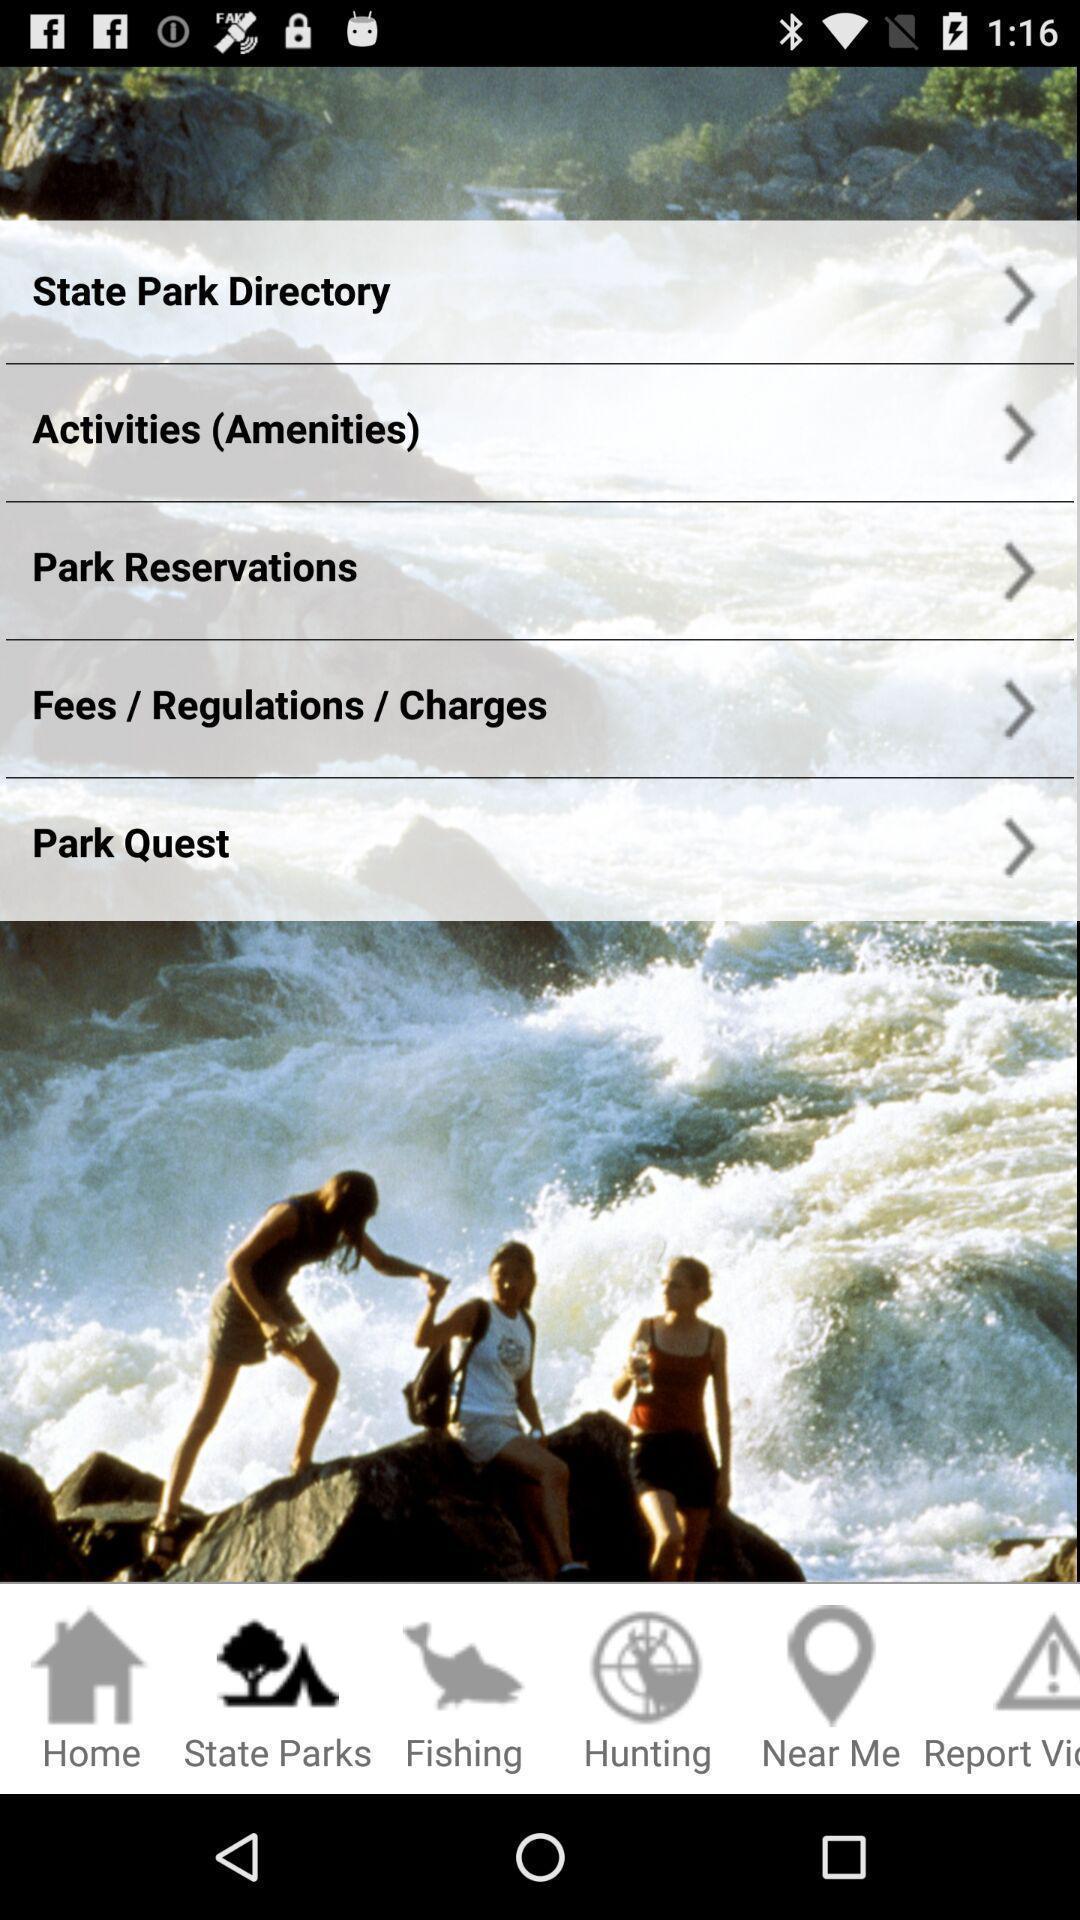Provide a detailed account of this screenshot. Social app showing list of parks. 